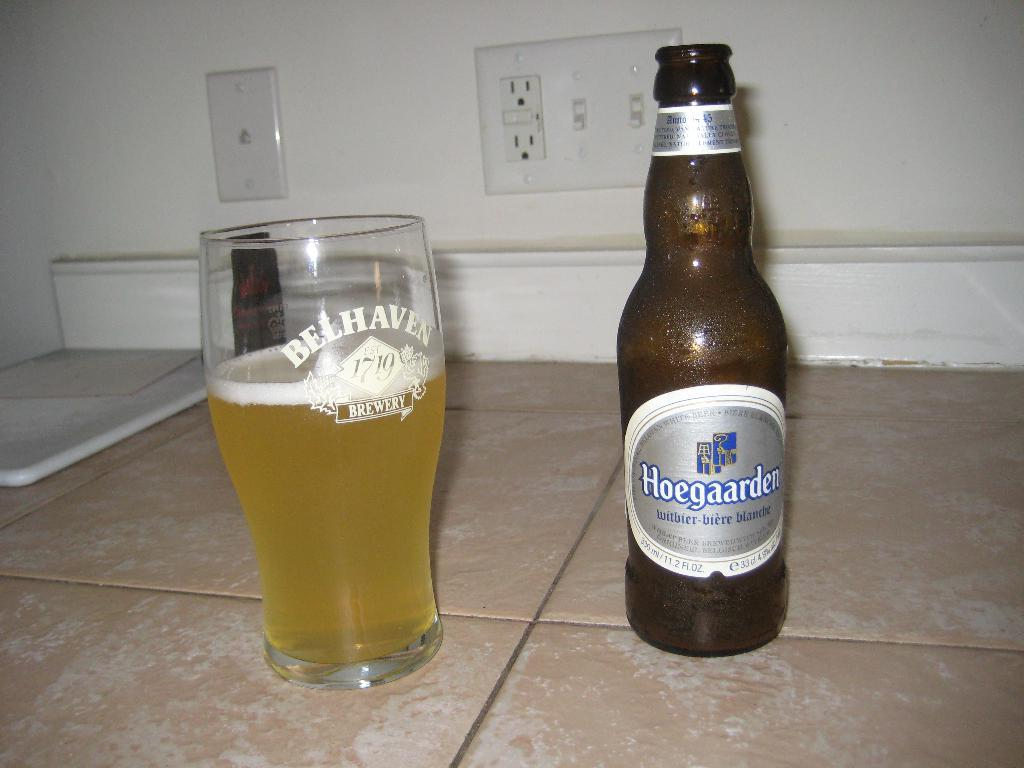<image>
Provide a brief description of the given image. A Hoegaarden witbier-biere blanche beer and a glass beside it. 